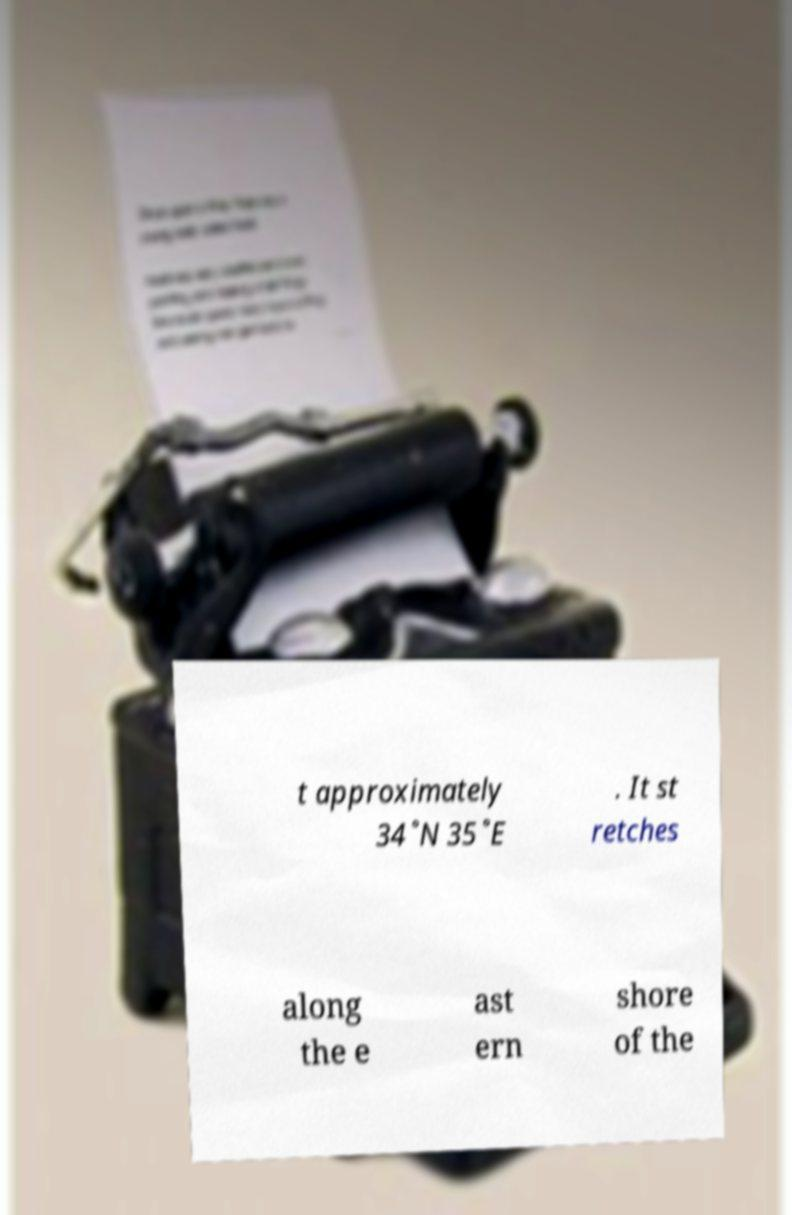What messages or text are displayed in this image? I need them in a readable, typed format. t approximately 34˚N 35˚E . It st retches along the e ast ern shore of the 